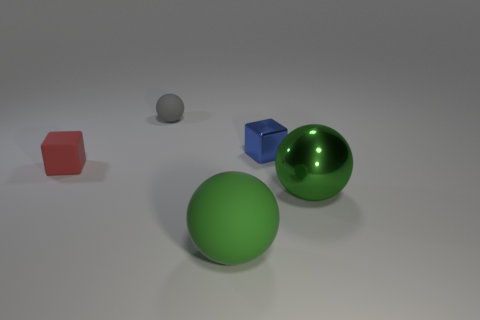Subtract all big green rubber spheres. How many spheres are left? 2 Subtract all green cubes. How many green spheres are left? 2 Add 5 blue shiny blocks. How many objects exist? 10 Subtract all gray spheres. How many spheres are left? 2 Subtract all spheres. How many objects are left? 2 Subtract all gray balls. Subtract all purple cubes. How many balls are left? 2 Subtract all matte objects. Subtract all cyan rubber balls. How many objects are left? 2 Add 1 small blue metallic things. How many small blue metallic things are left? 2 Add 5 large green balls. How many large green balls exist? 7 Subtract 0 yellow cubes. How many objects are left? 5 